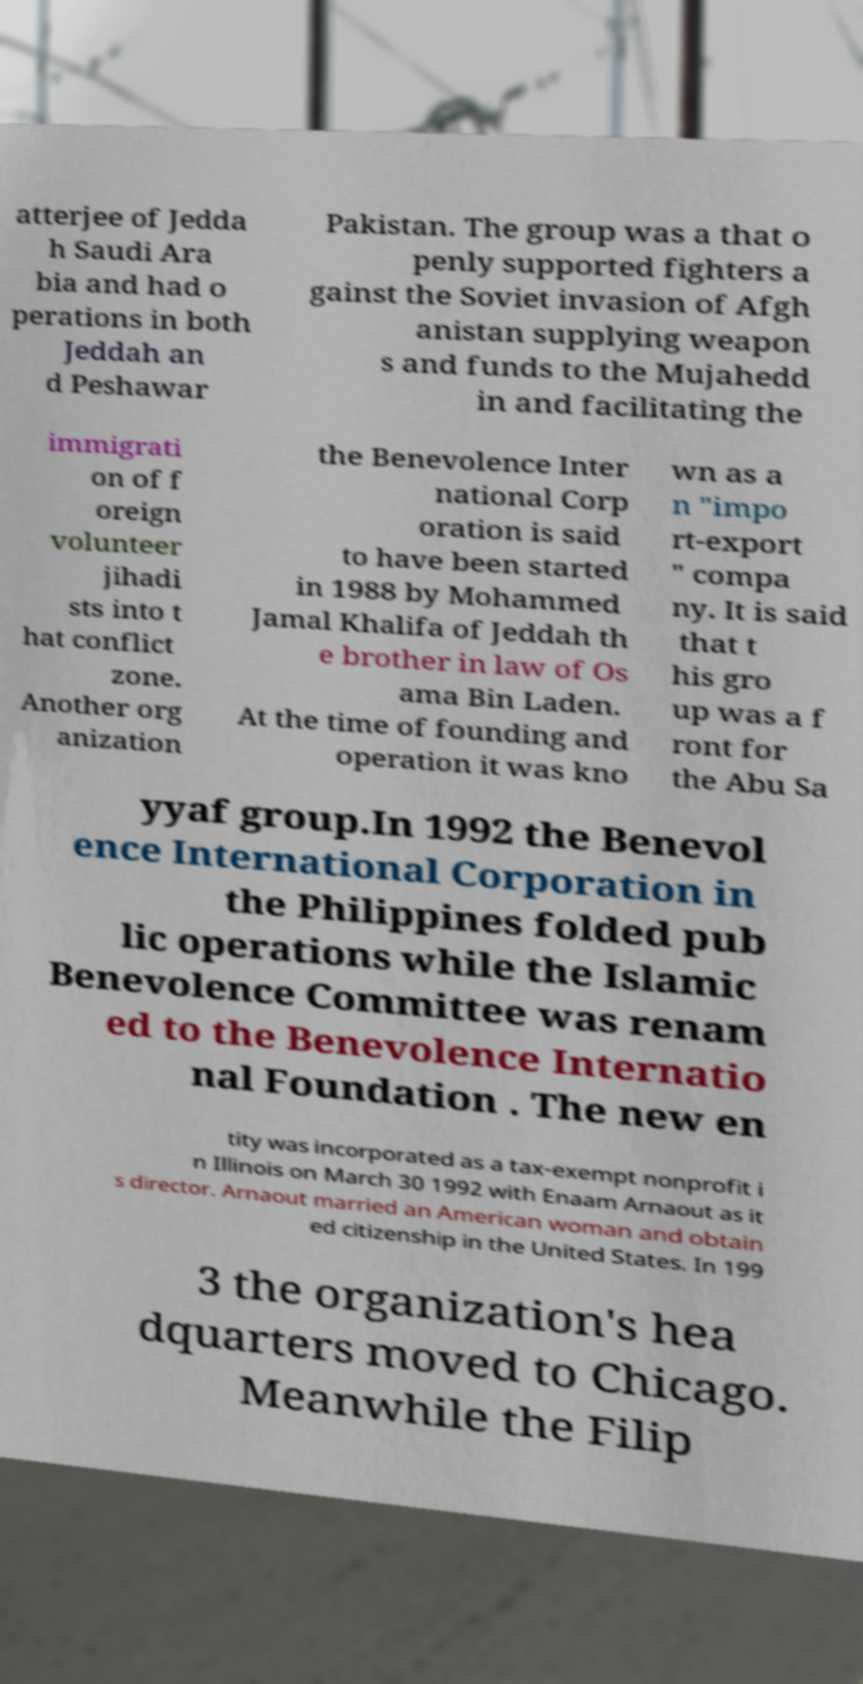Could you extract and type out the text from this image? atterjee of Jedda h Saudi Ara bia and had o perations in both Jeddah an d Peshawar Pakistan. The group was a that o penly supported fighters a gainst the Soviet invasion of Afgh anistan supplying weapon s and funds to the Mujahedd in and facilitating the immigrati on of f oreign volunteer jihadi sts into t hat conflict zone. Another org anization the Benevolence Inter national Corp oration is said to have been started in 1988 by Mohammed Jamal Khalifa of Jeddah th e brother in law of Os ama Bin Laden. At the time of founding and operation it was kno wn as a n "impo rt-export " compa ny. It is said that t his gro up was a f ront for the Abu Sa yyaf group.In 1992 the Benevol ence International Corporation in the Philippines folded pub lic operations while the Islamic Benevolence Committee was renam ed to the Benevolence Internatio nal Foundation . The new en tity was incorporated as a tax-exempt nonprofit i n Illinois on March 30 1992 with Enaam Arnaout as it s director. Arnaout married an American woman and obtain ed citizenship in the United States. In 199 3 the organization's hea dquarters moved to Chicago. Meanwhile the Filip 